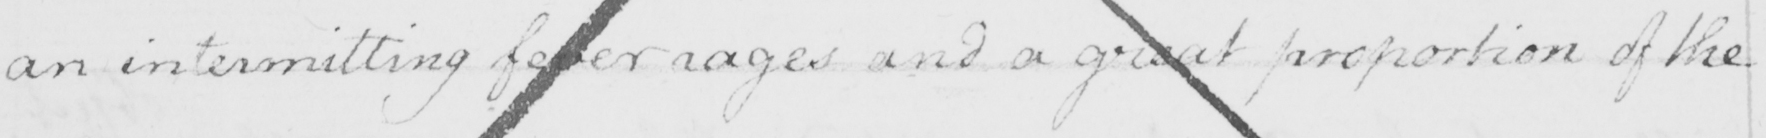Please provide the text content of this handwritten line. an intermitting fever rages and a great proportion of the 